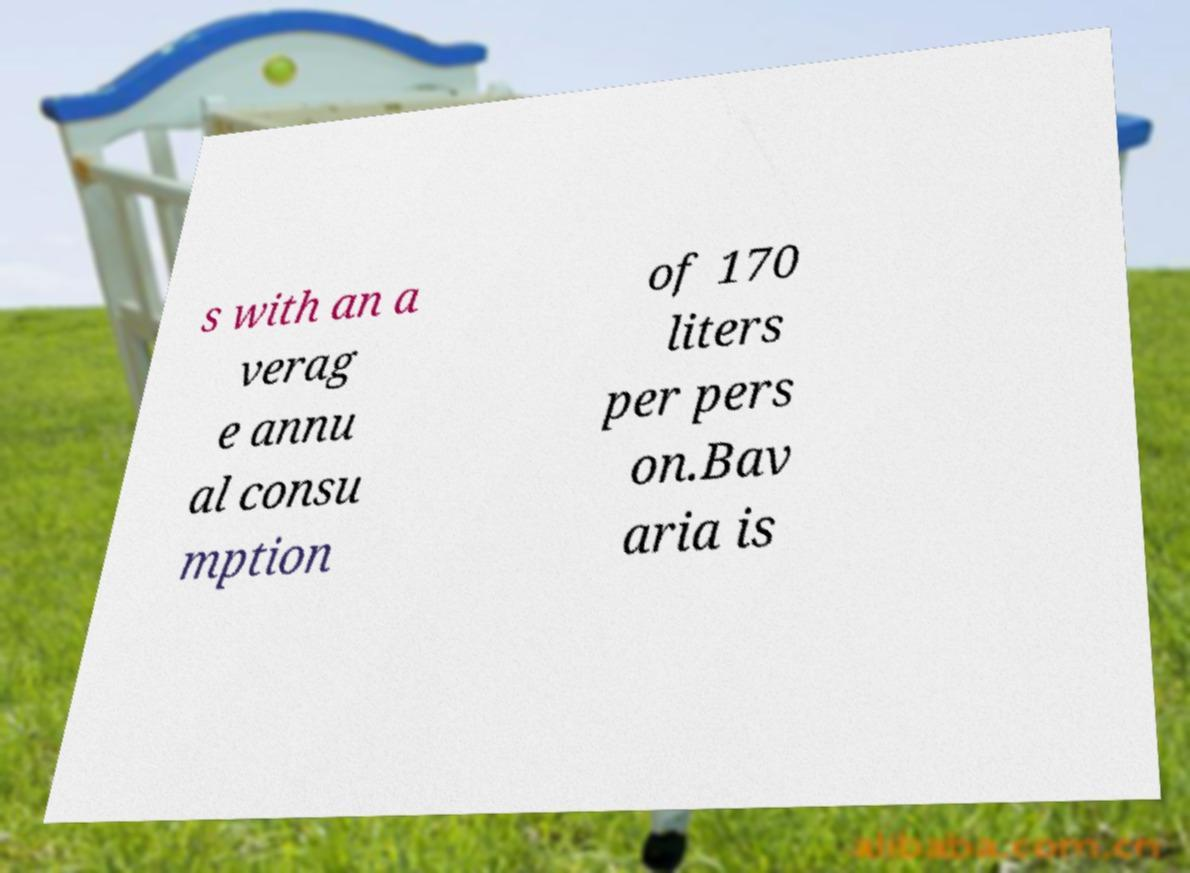What messages or text are displayed in this image? I need them in a readable, typed format. s with an a verag e annu al consu mption of 170 liters per pers on.Bav aria is 